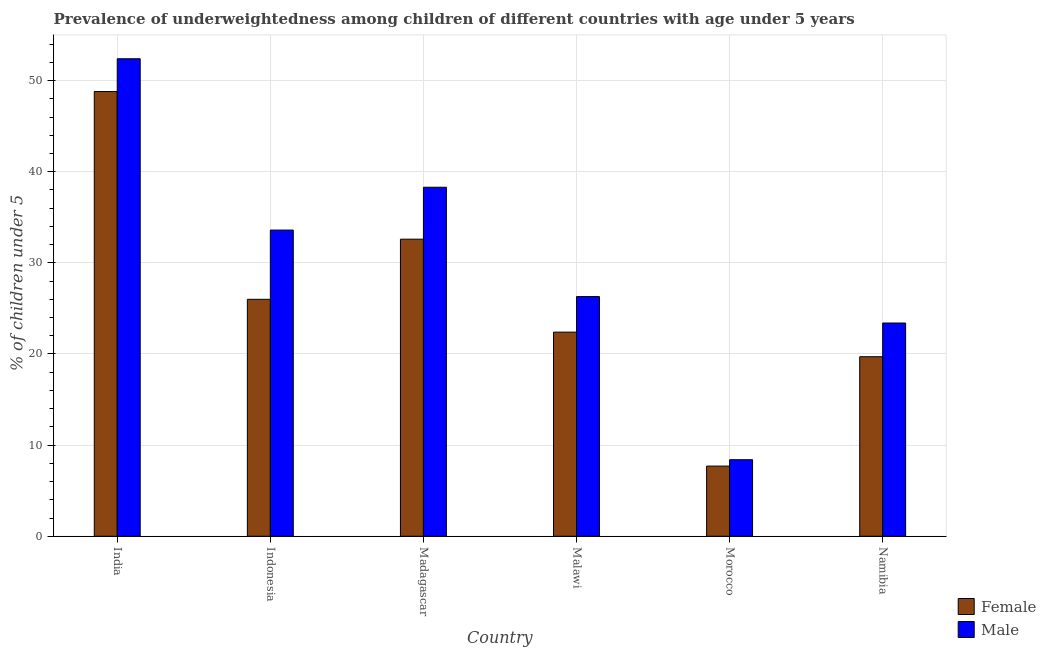How many groups of bars are there?
Keep it short and to the point. 6. Are the number of bars per tick equal to the number of legend labels?
Provide a succinct answer. Yes. Are the number of bars on each tick of the X-axis equal?
Provide a succinct answer. Yes. How many bars are there on the 6th tick from the right?
Keep it short and to the point. 2. What is the label of the 5th group of bars from the left?
Ensure brevity in your answer.  Morocco. What is the percentage of underweighted female children in Madagascar?
Your answer should be very brief. 32.6. Across all countries, what is the maximum percentage of underweighted female children?
Make the answer very short. 48.8. Across all countries, what is the minimum percentage of underweighted female children?
Your response must be concise. 7.7. In which country was the percentage of underweighted female children minimum?
Keep it short and to the point. Morocco. What is the total percentage of underweighted female children in the graph?
Make the answer very short. 157.2. What is the difference between the percentage of underweighted female children in Indonesia and that in Namibia?
Ensure brevity in your answer.  6.3. What is the difference between the percentage of underweighted female children in India and the percentage of underweighted male children in Namibia?
Your answer should be very brief. 25.4. What is the average percentage of underweighted female children per country?
Ensure brevity in your answer.  26.2. What is the difference between the percentage of underweighted male children and percentage of underweighted female children in Namibia?
Your response must be concise. 3.7. In how many countries, is the percentage of underweighted male children greater than 36 %?
Your answer should be very brief. 2. What is the ratio of the percentage of underweighted female children in Indonesia to that in Morocco?
Ensure brevity in your answer.  3.38. Is the difference between the percentage of underweighted male children in Indonesia and Namibia greater than the difference between the percentage of underweighted female children in Indonesia and Namibia?
Offer a terse response. Yes. What is the difference between the highest and the second highest percentage of underweighted male children?
Your response must be concise. 14.1. What is the difference between the highest and the lowest percentage of underweighted female children?
Keep it short and to the point. 41.1. Is the sum of the percentage of underweighted female children in Indonesia and Morocco greater than the maximum percentage of underweighted male children across all countries?
Your answer should be compact. No. What does the 1st bar from the left in Madagascar represents?
Give a very brief answer. Female. What does the 1st bar from the right in Namibia represents?
Offer a very short reply. Male. What is the difference between two consecutive major ticks on the Y-axis?
Give a very brief answer. 10. Are the values on the major ticks of Y-axis written in scientific E-notation?
Your answer should be very brief. No. What is the title of the graph?
Make the answer very short. Prevalence of underweightedness among children of different countries with age under 5 years. Does "Exports of goods" appear as one of the legend labels in the graph?
Offer a terse response. No. What is the label or title of the Y-axis?
Give a very brief answer.  % of children under 5. What is the  % of children under 5 of Female in India?
Offer a terse response. 48.8. What is the  % of children under 5 of Male in India?
Give a very brief answer. 52.4. What is the  % of children under 5 of Female in Indonesia?
Your response must be concise. 26. What is the  % of children under 5 in Male in Indonesia?
Offer a terse response. 33.6. What is the  % of children under 5 in Female in Madagascar?
Your response must be concise. 32.6. What is the  % of children under 5 of Male in Madagascar?
Provide a short and direct response. 38.3. What is the  % of children under 5 of Female in Malawi?
Make the answer very short. 22.4. What is the  % of children under 5 of Male in Malawi?
Offer a very short reply. 26.3. What is the  % of children under 5 in Female in Morocco?
Provide a succinct answer. 7.7. What is the  % of children under 5 in Male in Morocco?
Your answer should be very brief. 8.4. What is the  % of children under 5 of Female in Namibia?
Keep it short and to the point. 19.7. What is the  % of children under 5 of Male in Namibia?
Offer a terse response. 23.4. Across all countries, what is the maximum  % of children under 5 in Female?
Keep it short and to the point. 48.8. Across all countries, what is the maximum  % of children under 5 of Male?
Keep it short and to the point. 52.4. Across all countries, what is the minimum  % of children under 5 in Female?
Offer a very short reply. 7.7. Across all countries, what is the minimum  % of children under 5 in Male?
Your answer should be compact. 8.4. What is the total  % of children under 5 in Female in the graph?
Give a very brief answer. 157.2. What is the total  % of children under 5 of Male in the graph?
Offer a very short reply. 182.4. What is the difference between the  % of children under 5 in Female in India and that in Indonesia?
Provide a succinct answer. 22.8. What is the difference between the  % of children under 5 of Male in India and that in Madagascar?
Ensure brevity in your answer.  14.1. What is the difference between the  % of children under 5 of Female in India and that in Malawi?
Your response must be concise. 26.4. What is the difference between the  % of children under 5 in Male in India and that in Malawi?
Your response must be concise. 26.1. What is the difference between the  % of children under 5 in Female in India and that in Morocco?
Your answer should be compact. 41.1. What is the difference between the  % of children under 5 in Male in India and that in Morocco?
Your answer should be compact. 44. What is the difference between the  % of children under 5 of Female in India and that in Namibia?
Provide a succinct answer. 29.1. What is the difference between the  % of children under 5 of Female in Indonesia and that in Madagascar?
Your response must be concise. -6.6. What is the difference between the  % of children under 5 of Male in Indonesia and that in Malawi?
Make the answer very short. 7.3. What is the difference between the  % of children under 5 in Female in Indonesia and that in Morocco?
Give a very brief answer. 18.3. What is the difference between the  % of children under 5 in Male in Indonesia and that in Morocco?
Offer a terse response. 25.2. What is the difference between the  % of children under 5 in Female in Madagascar and that in Malawi?
Offer a very short reply. 10.2. What is the difference between the  % of children under 5 in Female in Madagascar and that in Morocco?
Provide a short and direct response. 24.9. What is the difference between the  % of children under 5 in Male in Madagascar and that in Morocco?
Provide a succinct answer. 29.9. What is the difference between the  % of children under 5 of Female in Malawi and that in Morocco?
Provide a succinct answer. 14.7. What is the difference between the  % of children under 5 of Male in Malawi and that in Namibia?
Your response must be concise. 2.9. What is the difference between the  % of children under 5 of Female in India and the  % of children under 5 of Male in Morocco?
Your answer should be compact. 40.4. What is the difference between the  % of children under 5 in Female in India and the  % of children under 5 in Male in Namibia?
Give a very brief answer. 25.4. What is the difference between the  % of children under 5 in Female in Indonesia and the  % of children under 5 in Male in Namibia?
Provide a succinct answer. 2.6. What is the difference between the  % of children under 5 in Female in Madagascar and the  % of children under 5 in Male in Morocco?
Provide a succinct answer. 24.2. What is the difference between the  % of children under 5 in Female in Malawi and the  % of children under 5 in Male in Morocco?
Your answer should be very brief. 14. What is the difference between the  % of children under 5 of Female in Morocco and the  % of children under 5 of Male in Namibia?
Your answer should be compact. -15.7. What is the average  % of children under 5 of Female per country?
Give a very brief answer. 26.2. What is the average  % of children under 5 of Male per country?
Your response must be concise. 30.4. What is the difference between the  % of children under 5 in Female and  % of children under 5 in Male in India?
Ensure brevity in your answer.  -3.6. What is the difference between the  % of children under 5 in Female and  % of children under 5 in Male in Indonesia?
Offer a very short reply. -7.6. What is the difference between the  % of children under 5 of Female and  % of children under 5 of Male in Madagascar?
Your answer should be very brief. -5.7. What is the difference between the  % of children under 5 in Female and  % of children under 5 in Male in Morocco?
Your answer should be compact. -0.7. What is the ratio of the  % of children under 5 of Female in India to that in Indonesia?
Offer a terse response. 1.88. What is the ratio of the  % of children under 5 in Male in India to that in Indonesia?
Provide a short and direct response. 1.56. What is the ratio of the  % of children under 5 in Female in India to that in Madagascar?
Your answer should be very brief. 1.5. What is the ratio of the  % of children under 5 in Male in India to that in Madagascar?
Keep it short and to the point. 1.37. What is the ratio of the  % of children under 5 of Female in India to that in Malawi?
Offer a very short reply. 2.18. What is the ratio of the  % of children under 5 of Male in India to that in Malawi?
Your answer should be compact. 1.99. What is the ratio of the  % of children under 5 in Female in India to that in Morocco?
Keep it short and to the point. 6.34. What is the ratio of the  % of children under 5 of Male in India to that in Morocco?
Offer a very short reply. 6.24. What is the ratio of the  % of children under 5 in Female in India to that in Namibia?
Give a very brief answer. 2.48. What is the ratio of the  % of children under 5 of Male in India to that in Namibia?
Provide a succinct answer. 2.24. What is the ratio of the  % of children under 5 in Female in Indonesia to that in Madagascar?
Your answer should be very brief. 0.8. What is the ratio of the  % of children under 5 of Male in Indonesia to that in Madagascar?
Make the answer very short. 0.88. What is the ratio of the  % of children under 5 of Female in Indonesia to that in Malawi?
Make the answer very short. 1.16. What is the ratio of the  % of children under 5 of Male in Indonesia to that in Malawi?
Offer a very short reply. 1.28. What is the ratio of the  % of children under 5 of Female in Indonesia to that in Morocco?
Offer a very short reply. 3.38. What is the ratio of the  % of children under 5 in Female in Indonesia to that in Namibia?
Your answer should be very brief. 1.32. What is the ratio of the  % of children under 5 in Male in Indonesia to that in Namibia?
Make the answer very short. 1.44. What is the ratio of the  % of children under 5 in Female in Madagascar to that in Malawi?
Your answer should be compact. 1.46. What is the ratio of the  % of children under 5 in Male in Madagascar to that in Malawi?
Provide a short and direct response. 1.46. What is the ratio of the  % of children under 5 of Female in Madagascar to that in Morocco?
Ensure brevity in your answer.  4.23. What is the ratio of the  % of children under 5 in Male in Madagascar to that in Morocco?
Provide a short and direct response. 4.56. What is the ratio of the  % of children under 5 in Female in Madagascar to that in Namibia?
Your answer should be very brief. 1.65. What is the ratio of the  % of children under 5 of Male in Madagascar to that in Namibia?
Offer a very short reply. 1.64. What is the ratio of the  % of children under 5 of Female in Malawi to that in Morocco?
Your answer should be very brief. 2.91. What is the ratio of the  % of children under 5 in Male in Malawi to that in Morocco?
Your answer should be compact. 3.13. What is the ratio of the  % of children under 5 of Female in Malawi to that in Namibia?
Keep it short and to the point. 1.14. What is the ratio of the  % of children under 5 of Male in Malawi to that in Namibia?
Make the answer very short. 1.12. What is the ratio of the  % of children under 5 of Female in Morocco to that in Namibia?
Give a very brief answer. 0.39. What is the ratio of the  % of children under 5 of Male in Morocco to that in Namibia?
Provide a succinct answer. 0.36. What is the difference between the highest and the second highest  % of children under 5 of Female?
Make the answer very short. 16.2. What is the difference between the highest and the second highest  % of children under 5 of Male?
Offer a terse response. 14.1. What is the difference between the highest and the lowest  % of children under 5 of Female?
Keep it short and to the point. 41.1. 